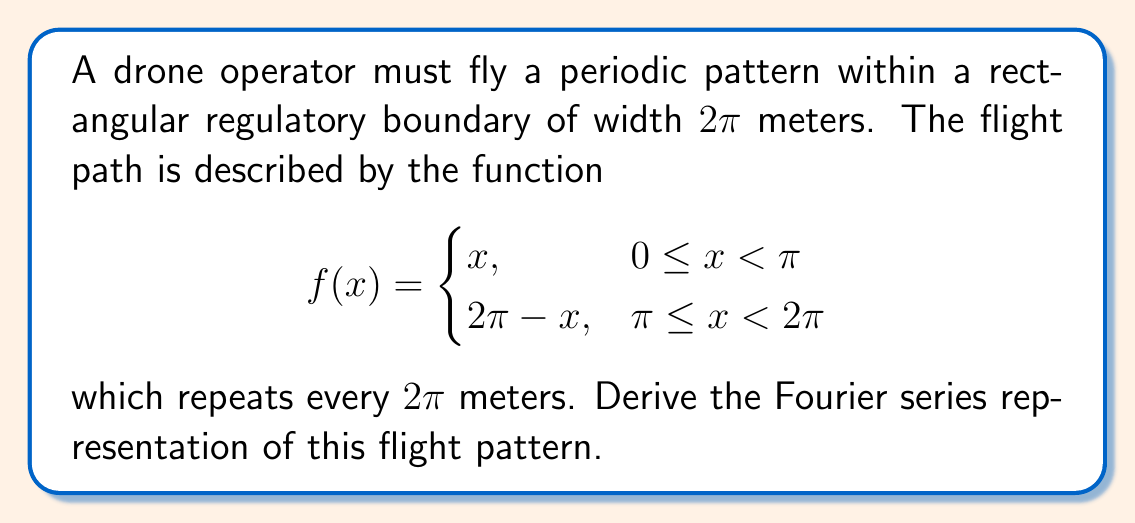Provide a solution to this math problem. To derive the Fourier series representation, we follow these steps:

1) The Fourier series for a periodic function $f(x)$ with period $2\pi$ is given by:

   $f(x) = \frac{a_0}{2} + \sum_{n=1}^{\infty} (a_n \cos(nx) + b_n \sin(nx))$

   where $a_0$, $a_n$, and $b_n$ are Fourier coefficients.

2) Calculate $a_0$:
   $a_0 = \frac{1}{\pi} \int_0^{2\pi} f(x) dx$
   $= \frac{1}{\pi} (\int_0^{\pi} x dx + \int_{\pi}^{2\pi} (2\pi - x) dx)$
   $= \frac{1}{\pi} (\frac{\pi^2}{2} + \frac{\pi^2}{2}) = \pi$

3) Calculate $a_n$:
   $a_n = \frac{1}{\pi} \int_0^{2\pi} f(x) \cos(nx) dx$
   $= \frac{1}{\pi} (\int_0^{\pi} x \cos(nx) dx + \int_{\pi}^{2\pi} (2\pi - x) \cos(nx) dx)$
   After integration and simplification:
   $a_n = \frac{4}{n^2\pi} (\cos(n\pi) - 1)$ for $n \geq 1$

4) Calculate $b_n$:
   $b_n = \frac{1}{\pi} \int_0^{2\pi} f(x) \sin(nx) dx$
   $= \frac{1}{\pi} (\int_0^{\pi} x \sin(nx) dx + \int_{\pi}^{2\pi} (2\pi - x) \sin(nx) dx)$
   After integration and simplification:
   $b_n = -\frac{2}{n\pi}$ for odd $n$, and $0$ for even $n$

5) Substituting these coefficients into the Fourier series:

   $f(x) = \frac{\pi}{2} + \sum_{n=1}^{\infty} (\frac{4}{n^2\pi} (\cos(n\pi) - 1) \cos(nx) - \frac{2}{n\pi} \sin(nx))$

   Note that $\cos(n\pi) - 1 = -2$ for odd $n$ and $0$ for even $n$.

6) Simplifying further:

   $f(x) = \frac{\pi}{2} - \sum_{n=1,3,5,...}^{\infty} (\frac{8}{n^2\pi} \cos(nx) + \frac{2}{n\pi} \sin(nx))$
Answer: $f(x) = \frac{\pi}{2} - \sum_{n=1,3,5,...}^{\infty} (\frac{8}{n^2\pi} \cos(nx) + \frac{2}{n\pi} \sin(nx))$ 